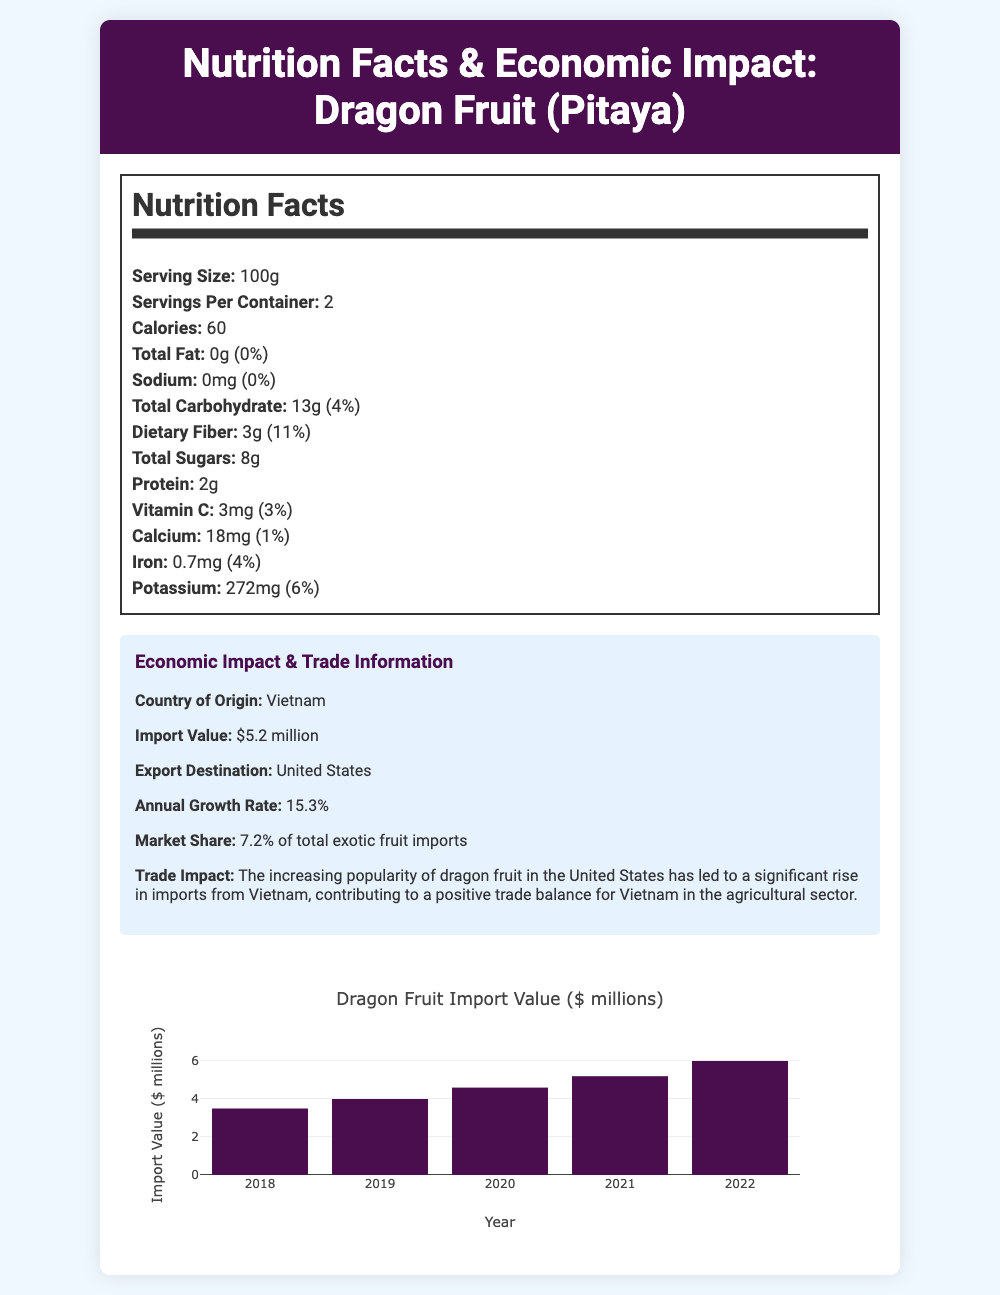what is the serving size for dragon fruit? According to the Nutrition Facts section, the serving size is listed as 100g.
Answer: 100g how many calories are in one serving of dragon fruit? The Nutrition Facts state that there are 60 calories per serving.
Answer: 60 what is the country of origin for this dragon fruit? The Economic Impact & Trade Information section mentions that the country of origin is Vietnam.
Answer: Vietnam how much protein does one serving of dragon fruit contain? The Nutrition Facts section indicates that there are 2g of protein per serving.
Answer: 2g what is the annual growth rate for dragon fruit imports? The Trade Impact portion mentions that the annual growth rate for dragon fruit imports is 15.3%.
Answer: 15.3% which nutrient in dragon fruit has the highest daily value percentage?A. Vitamin C B. Calcium C. Iron D. Potassium Iron has the highest daily value percentage at 4%.
Answer: C what is the peak import season for dragon fruit? A. January to March B. April to June C. June to September D. October to December The Market Dynamics section states that the peak import season is from June to September.
Answer: C is dragon fruit relatively inelastic? Yes/No The Market Dynamics section mentions that dragon fruit has a relatively inelastic price due to its unique characteristics and limited substitutes.
Answer: Yes describe the economic implications mentioned in the document. The economic implications section mentions that dragon fruit imports contribute to Vietnam's foreign exchange earnings, promote rural development and job creation in agricultural regions, and stimulate investment in cold chain logistics and transportation infrastructure.
Answer: Contributes to foreign exchange earnings, supports rural development, and stimulates investment in logistics. how does social media influence the popularity of dragon fruit? The Consumer Trends section indicates that the Instagram-worthy appearance of dragon fruit drives its popularity among millennials.
Answer: Instagram-worthy appearance can you find the exact export value of dragon fruit in 2021 from the document? The document provides the import value over several years but does not specify the export value for a specific year like 2021.
Answer: Not enough information which countries are emerging as competitors to Vietnam for dragon fruit in the US market? The Market Dynamics section notes that Thailand and Malaysia are emerging as competitors in the US market.
Answer: Thailand and Malaysia what market share does dragon fruit hold in the total exotic fruit imports? The Trade Impact section states that dragon fruit holds a market share of 7.2% of total exotic fruit imports.
Answer: 7.2% explain the tariff applied to the import of dragon fruit under US trade policies. The Trade Policies section mentions that dragon fruit is subject to a 2.2% import tariff under the US Generalized System of Preferences.
Answer: 2.2% import tariff under the US Generalized System of Preferences what are the labeling requirements for imported dragon fruit in the US? The Trade Policies section explains that imported dragon fruit must adhere to FDA nutrition labeling standards.
Answer: Adherence to FDA nutrition labeling standards summarize the Consumer Trends related to dragon fruit. The Consumer Trends section describes an increasing demand for dragon fruit owing to its health benefits, social media influence, and its use in fusion cuisine and gourmet recipes.
Answer: Growing demand due to health benefits, popularity driven by social media, and use in fusion cuisine. 